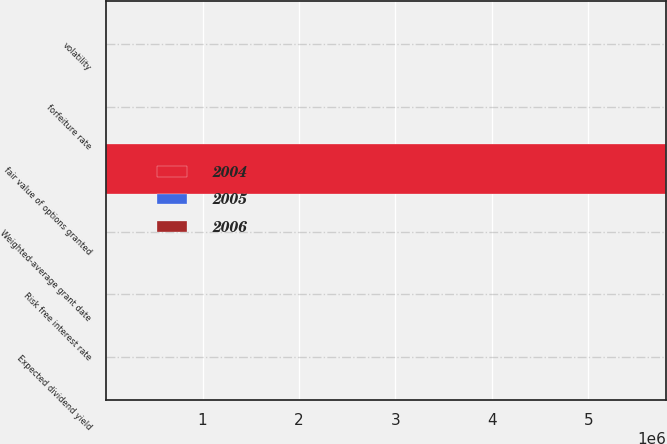<chart> <loc_0><loc_0><loc_500><loc_500><stacked_bar_chart><ecel><fcel>Expected dividend yield<fcel>forfeiture rate<fcel>volatility<fcel>Risk free interest rate<fcel>fair value of options granted<fcel>Weighted-average grant date<nl><fcel>2004<fcel>0<fcel>7.43<fcel>38.3<fcel>4.58<fcel>5.802e+06<fcel>14.22<nl><fcel>2006<fcel>0<fcel>0<fcel>38.44<fcel>3.74<fcel>6.005<fcel>17.16<nl><fcel>2005<fcel>0<fcel>0<fcel>50<fcel>3.25<fcel>6.005<fcel>24.56<nl></chart> 